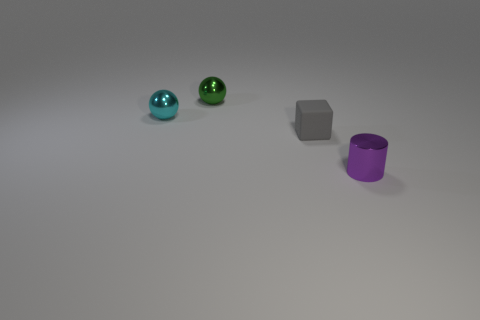What color is the cylinder that is the same size as the green shiny thing?
Ensure brevity in your answer.  Purple. Do the green shiny sphere and the matte thing have the same size?
Your answer should be very brief. Yes. There is a tiny thing that is behind the gray rubber block and in front of the tiny green metallic sphere; what color is it?
Offer a terse response. Cyan. Is the number of tiny objects in front of the matte thing greater than the number of tiny metal cylinders that are left of the purple metal object?
Offer a very short reply. Yes. How many rubber things are behind the tiny purple object in front of the cyan metal ball?
Your answer should be very brief. 1. Are there any other things of the same shape as the small green thing?
Make the answer very short. Yes. What color is the shiny ball that is in front of the tiny green object to the left of the gray rubber thing?
Your response must be concise. Cyan. Is the number of tiny blue cubes greater than the number of gray blocks?
Offer a very short reply. No. What number of purple cylinders have the same size as the cyan metal ball?
Make the answer very short. 1. Is the material of the cyan object the same as the gray object that is to the right of the tiny green object?
Offer a terse response. No. 